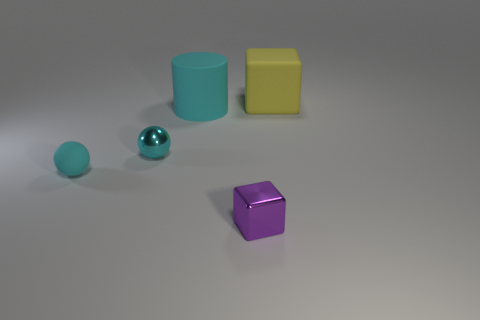Are there fewer metal cubes that are left of the purple metallic cube than small balls that are behind the matte cube?
Offer a very short reply. No. Is the material of the large object in front of the large yellow cube the same as the object that is to the right of the small purple thing?
Your answer should be very brief. Yes. What is the shape of the tiny cyan rubber object?
Your answer should be very brief. Sphere. Are there more large things right of the cyan cylinder than yellow cubes that are on the left side of the matte block?
Offer a terse response. Yes. There is a tiny cyan thing that is in front of the shiny ball; is its shape the same as the tiny metallic thing that is behind the purple thing?
Offer a terse response. Yes. What number of other objects are there of the same size as the yellow cube?
Your answer should be very brief. 1. The purple object is what size?
Provide a short and direct response. Small. Does the large thing that is on the left side of the tiny purple metal cube have the same material as the large yellow cube?
Keep it short and to the point. Yes. What color is the matte object that is the same shape as the purple metallic thing?
Offer a very short reply. Yellow. There is a shiny object that is on the left side of the cylinder; does it have the same color as the small rubber object?
Your answer should be compact. Yes. 